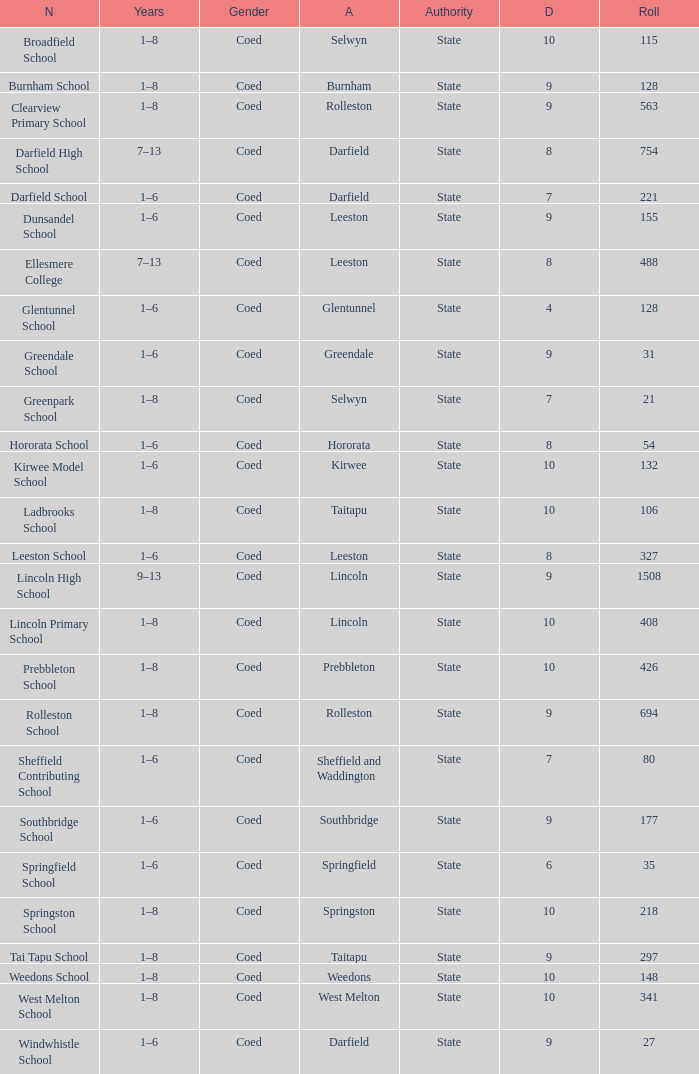Which name has a Roll larger than 297, and Years of 7–13? Darfield High School, Ellesmere College. 